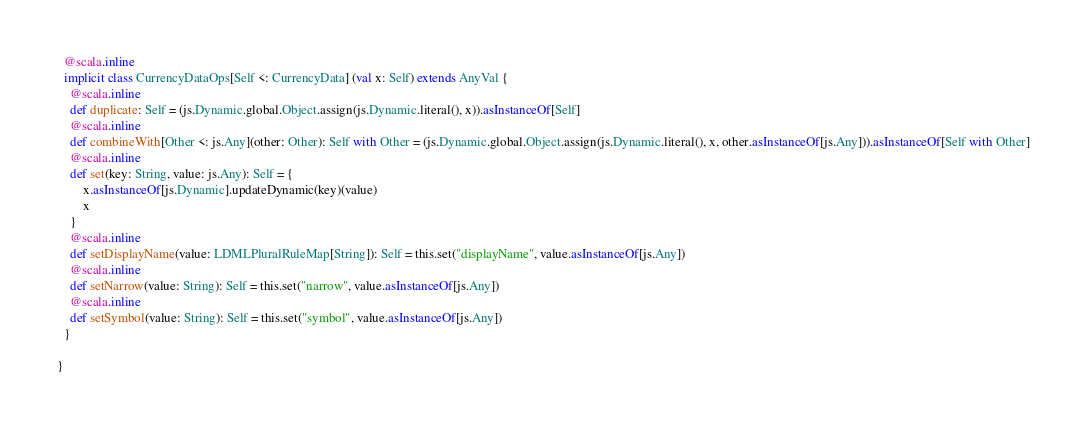<code> <loc_0><loc_0><loc_500><loc_500><_Scala_>  @scala.inline
  implicit class CurrencyDataOps[Self <: CurrencyData] (val x: Self) extends AnyVal {
    @scala.inline
    def duplicate: Self = (js.Dynamic.global.Object.assign(js.Dynamic.literal(), x)).asInstanceOf[Self]
    @scala.inline
    def combineWith[Other <: js.Any](other: Other): Self with Other = (js.Dynamic.global.Object.assign(js.Dynamic.literal(), x, other.asInstanceOf[js.Any])).asInstanceOf[Self with Other]
    @scala.inline
    def set(key: String, value: js.Any): Self = {
        x.asInstanceOf[js.Dynamic].updateDynamic(key)(value)
        x
    }
    @scala.inline
    def setDisplayName(value: LDMLPluralRuleMap[String]): Self = this.set("displayName", value.asInstanceOf[js.Any])
    @scala.inline
    def setNarrow(value: String): Self = this.set("narrow", value.asInstanceOf[js.Any])
    @scala.inline
    def setSymbol(value: String): Self = this.set("symbol", value.asInstanceOf[js.Any])
  }
  
}

</code> 